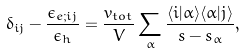<formula> <loc_0><loc_0><loc_500><loc_500>\delta _ { i j } - \frac { \epsilon _ { e ; i j } } { \epsilon _ { h } } = \frac { v _ { t o t } } { V } \sum _ { \alpha } \frac { \langle i | \alpha \rangle \langle \alpha | j \rangle } { s - s _ { \alpha } } ,</formula> 